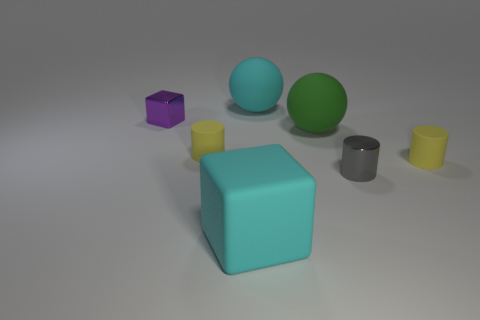Is the green thing the same size as the purple object?
Offer a terse response. No. There is a thing that is right of the purple metallic thing and left of the big cyan cube; what is its color?
Ensure brevity in your answer.  Yellow. There is a cyan thing that is in front of the tiny matte cylinder to the left of the small gray object; what is it made of?
Provide a succinct answer. Rubber. What size is the cyan matte thing that is the same shape as the purple shiny object?
Your response must be concise. Large. There is a big rubber ball behind the tiny purple thing; is its color the same as the large cube?
Offer a terse response. Yes. Are there fewer big rubber cubes than balls?
Your response must be concise. Yes. What number of other objects are the same color as the big block?
Offer a terse response. 1. Does the yellow cylinder that is on the left side of the big matte cube have the same material as the purple cube?
Keep it short and to the point. No. There is a yellow thing to the left of the big cyan matte ball; what material is it?
Your answer should be very brief. Rubber. What size is the cyan thing that is behind the gray shiny cylinder that is to the right of the cyan ball?
Give a very brief answer. Large. 